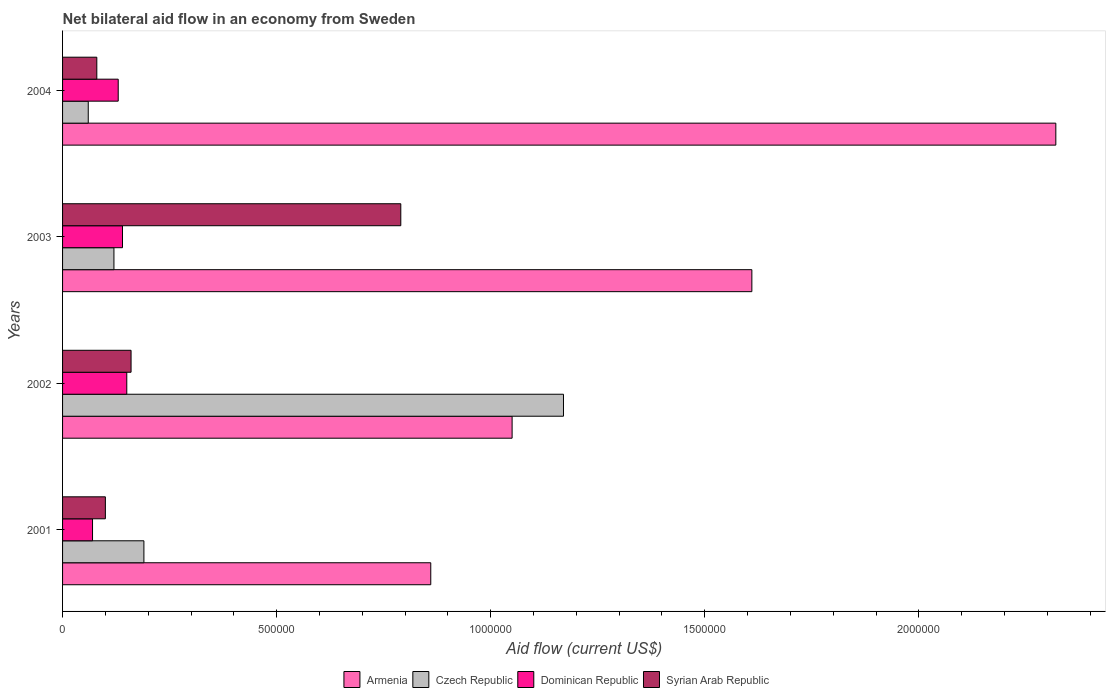How many groups of bars are there?
Make the answer very short. 4. How many bars are there on the 1st tick from the top?
Your response must be concise. 4. What is the net bilateral aid flow in Armenia in 2001?
Your answer should be very brief. 8.60e+05. Across all years, what is the maximum net bilateral aid flow in Syrian Arab Republic?
Provide a succinct answer. 7.90e+05. Across all years, what is the minimum net bilateral aid flow in Czech Republic?
Make the answer very short. 6.00e+04. In which year was the net bilateral aid flow in Armenia minimum?
Your answer should be very brief. 2001. What is the total net bilateral aid flow in Syrian Arab Republic in the graph?
Ensure brevity in your answer.  1.13e+06. What is the average net bilateral aid flow in Armenia per year?
Your response must be concise. 1.46e+06. In the year 2003, what is the difference between the net bilateral aid flow in Czech Republic and net bilateral aid flow in Armenia?
Give a very brief answer. -1.49e+06. What is the ratio of the net bilateral aid flow in Dominican Republic in 2001 to that in 2002?
Your response must be concise. 0.47. Is the net bilateral aid flow in Dominican Republic in 2001 less than that in 2003?
Give a very brief answer. Yes. Is the difference between the net bilateral aid flow in Czech Republic in 2001 and 2003 greater than the difference between the net bilateral aid flow in Armenia in 2001 and 2003?
Your answer should be very brief. Yes. What is the difference between the highest and the second highest net bilateral aid flow in Czech Republic?
Offer a terse response. 9.80e+05. In how many years, is the net bilateral aid flow in Dominican Republic greater than the average net bilateral aid flow in Dominican Republic taken over all years?
Offer a terse response. 3. Is the sum of the net bilateral aid flow in Czech Republic in 2001 and 2003 greater than the maximum net bilateral aid flow in Syrian Arab Republic across all years?
Offer a very short reply. No. What does the 1st bar from the top in 2003 represents?
Provide a short and direct response. Syrian Arab Republic. What does the 3rd bar from the bottom in 2003 represents?
Keep it short and to the point. Dominican Republic. Is it the case that in every year, the sum of the net bilateral aid flow in Dominican Republic and net bilateral aid flow in Syrian Arab Republic is greater than the net bilateral aid flow in Czech Republic?
Your answer should be very brief. No. How many bars are there?
Provide a short and direct response. 16. What is the difference between two consecutive major ticks on the X-axis?
Ensure brevity in your answer.  5.00e+05. How many legend labels are there?
Give a very brief answer. 4. What is the title of the graph?
Ensure brevity in your answer.  Net bilateral aid flow in an economy from Sweden. What is the label or title of the Y-axis?
Provide a succinct answer. Years. What is the Aid flow (current US$) in Armenia in 2001?
Give a very brief answer. 8.60e+05. What is the Aid flow (current US$) of Czech Republic in 2001?
Offer a terse response. 1.90e+05. What is the Aid flow (current US$) in Armenia in 2002?
Provide a short and direct response. 1.05e+06. What is the Aid flow (current US$) of Czech Republic in 2002?
Offer a very short reply. 1.17e+06. What is the Aid flow (current US$) of Armenia in 2003?
Your answer should be compact. 1.61e+06. What is the Aid flow (current US$) in Czech Republic in 2003?
Your answer should be compact. 1.20e+05. What is the Aid flow (current US$) of Syrian Arab Republic in 2003?
Offer a very short reply. 7.90e+05. What is the Aid flow (current US$) in Armenia in 2004?
Offer a very short reply. 2.32e+06. What is the Aid flow (current US$) of Czech Republic in 2004?
Provide a short and direct response. 6.00e+04. What is the Aid flow (current US$) in Dominican Republic in 2004?
Ensure brevity in your answer.  1.30e+05. Across all years, what is the maximum Aid flow (current US$) in Armenia?
Keep it short and to the point. 2.32e+06. Across all years, what is the maximum Aid flow (current US$) in Czech Republic?
Your response must be concise. 1.17e+06. Across all years, what is the maximum Aid flow (current US$) in Dominican Republic?
Your answer should be compact. 1.50e+05. Across all years, what is the maximum Aid flow (current US$) in Syrian Arab Republic?
Your response must be concise. 7.90e+05. Across all years, what is the minimum Aid flow (current US$) of Armenia?
Offer a very short reply. 8.60e+05. Across all years, what is the minimum Aid flow (current US$) of Syrian Arab Republic?
Your answer should be very brief. 8.00e+04. What is the total Aid flow (current US$) of Armenia in the graph?
Provide a succinct answer. 5.84e+06. What is the total Aid flow (current US$) in Czech Republic in the graph?
Your response must be concise. 1.54e+06. What is the total Aid flow (current US$) in Dominican Republic in the graph?
Keep it short and to the point. 4.90e+05. What is the total Aid flow (current US$) in Syrian Arab Republic in the graph?
Offer a terse response. 1.13e+06. What is the difference between the Aid flow (current US$) of Czech Republic in 2001 and that in 2002?
Give a very brief answer. -9.80e+05. What is the difference between the Aid flow (current US$) of Armenia in 2001 and that in 2003?
Offer a very short reply. -7.50e+05. What is the difference between the Aid flow (current US$) in Syrian Arab Republic in 2001 and that in 2003?
Provide a short and direct response. -6.90e+05. What is the difference between the Aid flow (current US$) in Armenia in 2001 and that in 2004?
Your answer should be very brief. -1.46e+06. What is the difference between the Aid flow (current US$) of Syrian Arab Republic in 2001 and that in 2004?
Offer a terse response. 2.00e+04. What is the difference between the Aid flow (current US$) of Armenia in 2002 and that in 2003?
Your response must be concise. -5.60e+05. What is the difference between the Aid flow (current US$) in Czech Republic in 2002 and that in 2003?
Ensure brevity in your answer.  1.05e+06. What is the difference between the Aid flow (current US$) in Dominican Republic in 2002 and that in 2003?
Keep it short and to the point. 10000. What is the difference between the Aid flow (current US$) in Syrian Arab Republic in 2002 and that in 2003?
Make the answer very short. -6.30e+05. What is the difference between the Aid flow (current US$) of Armenia in 2002 and that in 2004?
Keep it short and to the point. -1.27e+06. What is the difference between the Aid flow (current US$) in Czech Republic in 2002 and that in 2004?
Provide a succinct answer. 1.11e+06. What is the difference between the Aid flow (current US$) of Dominican Republic in 2002 and that in 2004?
Give a very brief answer. 2.00e+04. What is the difference between the Aid flow (current US$) of Syrian Arab Republic in 2002 and that in 2004?
Your answer should be very brief. 8.00e+04. What is the difference between the Aid flow (current US$) in Armenia in 2003 and that in 2004?
Offer a very short reply. -7.10e+05. What is the difference between the Aid flow (current US$) of Czech Republic in 2003 and that in 2004?
Your response must be concise. 6.00e+04. What is the difference between the Aid flow (current US$) in Dominican Republic in 2003 and that in 2004?
Your answer should be very brief. 10000. What is the difference between the Aid flow (current US$) in Syrian Arab Republic in 2003 and that in 2004?
Make the answer very short. 7.10e+05. What is the difference between the Aid flow (current US$) in Armenia in 2001 and the Aid flow (current US$) in Czech Republic in 2002?
Provide a succinct answer. -3.10e+05. What is the difference between the Aid flow (current US$) of Armenia in 2001 and the Aid flow (current US$) of Dominican Republic in 2002?
Give a very brief answer. 7.10e+05. What is the difference between the Aid flow (current US$) in Czech Republic in 2001 and the Aid flow (current US$) in Dominican Republic in 2002?
Give a very brief answer. 4.00e+04. What is the difference between the Aid flow (current US$) in Armenia in 2001 and the Aid flow (current US$) in Czech Republic in 2003?
Provide a succinct answer. 7.40e+05. What is the difference between the Aid flow (current US$) in Armenia in 2001 and the Aid flow (current US$) in Dominican Republic in 2003?
Ensure brevity in your answer.  7.20e+05. What is the difference between the Aid flow (current US$) in Armenia in 2001 and the Aid flow (current US$) in Syrian Arab Republic in 2003?
Your answer should be compact. 7.00e+04. What is the difference between the Aid flow (current US$) of Czech Republic in 2001 and the Aid flow (current US$) of Syrian Arab Republic in 2003?
Offer a terse response. -6.00e+05. What is the difference between the Aid flow (current US$) of Dominican Republic in 2001 and the Aid flow (current US$) of Syrian Arab Republic in 2003?
Your response must be concise. -7.20e+05. What is the difference between the Aid flow (current US$) of Armenia in 2001 and the Aid flow (current US$) of Czech Republic in 2004?
Your answer should be compact. 8.00e+05. What is the difference between the Aid flow (current US$) in Armenia in 2001 and the Aid flow (current US$) in Dominican Republic in 2004?
Keep it short and to the point. 7.30e+05. What is the difference between the Aid flow (current US$) of Armenia in 2001 and the Aid flow (current US$) of Syrian Arab Republic in 2004?
Offer a terse response. 7.80e+05. What is the difference between the Aid flow (current US$) of Czech Republic in 2001 and the Aid flow (current US$) of Dominican Republic in 2004?
Your response must be concise. 6.00e+04. What is the difference between the Aid flow (current US$) of Armenia in 2002 and the Aid flow (current US$) of Czech Republic in 2003?
Make the answer very short. 9.30e+05. What is the difference between the Aid flow (current US$) in Armenia in 2002 and the Aid flow (current US$) in Dominican Republic in 2003?
Your response must be concise. 9.10e+05. What is the difference between the Aid flow (current US$) of Armenia in 2002 and the Aid flow (current US$) of Syrian Arab Republic in 2003?
Give a very brief answer. 2.60e+05. What is the difference between the Aid flow (current US$) of Czech Republic in 2002 and the Aid flow (current US$) of Dominican Republic in 2003?
Your answer should be compact. 1.03e+06. What is the difference between the Aid flow (current US$) in Dominican Republic in 2002 and the Aid flow (current US$) in Syrian Arab Republic in 2003?
Keep it short and to the point. -6.40e+05. What is the difference between the Aid flow (current US$) of Armenia in 2002 and the Aid flow (current US$) of Czech Republic in 2004?
Give a very brief answer. 9.90e+05. What is the difference between the Aid flow (current US$) of Armenia in 2002 and the Aid flow (current US$) of Dominican Republic in 2004?
Your answer should be compact. 9.20e+05. What is the difference between the Aid flow (current US$) of Armenia in 2002 and the Aid flow (current US$) of Syrian Arab Republic in 2004?
Ensure brevity in your answer.  9.70e+05. What is the difference between the Aid flow (current US$) in Czech Republic in 2002 and the Aid flow (current US$) in Dominican Republic in 2004?
Offer a very short reply. 1.04e+06. What is the difference between the Aid flow (current US$) in Czech Republic in 2002 and the Aid flow (current US$) in Syrian Arab Republic in 2004?
Provide a succinct answer. 1.09e+06. What is the difference between the Aid flow (current US$) in Dominican Republic in 2002 and the Aid flow (current US$) in Syrian Arab Republic in 2004?
Make the answer very short. 7.00e+04. What is the difference between the Aid flow (current US$) of Armenia in 2003 and the Aid flow (current US$) of Czech Republic in 2004?
Offer a terse response. 1.55e+06. What is the difference between the Aid flow (current US$) in Armenia in 2003 and the Aid flow (current US$) in Dominican Republic in 2004?
Your answer should be very brief. 1.48e+06. What is the difference between the Aid flow (current US$) in Armenia in 2003 and the Aid flow (current US$) in Syrian Arab Republic in 2004?
Provide a succinct answer. 1.53e+06. What is the difference between the Aid flow (current US$) in Dominican Republic in 2003 and the Aid flow (current US$) in Syrian Arab Republic in 2004?
Offer a very short reply. 6.00e+04. What is the average Aid flow (current US$) of Armenia per year?
Provide a short and direct response. 1.46e+06. What is the average Aid flow (current US$) of Czech Republic per year?
Provide a succinct answer. 3.85e+05. What is the average Aid flow (current US$) of Dominican Republic per year?
Your answer should be compact. 1.22e+05. What is the average Aid flow (current US$) in Syrian Arab Republic per year?
Keep it short and to the point. 2.82e+05. In the year 2001, what is the difference between the Aid flow (current US$) in Armenia and Aid flow (current US$) in Czech Republic?
Keep it short and to the point. 6.70e+05. In the year 2001, what is the difference between the Aid flow (current US$) in Armenia and Aid flow (current US$) in Dominican Republic?
Offer a terse response. 7.90e+05. In the year 2001, what is the difference between the Aid flow (current US$) in Armenia and Aid flow (current US$) in Syrian Arab Republic?
Your answer should be very brief. 7.60e+05. In the year 2001, what is the difference between the Aid flow (current US$) in Czech Republic and Aid flow (current US$) in Syrian Arab Republic?
Your response must be concise. 9.00e+04. In the year 2001, what is the difference between the Aid flow (current US$) of Dominican Republic and Aid flow (current US$) of Syrian Arab Republic?
Make the answer very short. -3.00e+04. In the year 2002, what is the difference between the Aid flow (current US$) in Armenia and Aid flow (current US$) in Czech Republic?
Keep it short and to the point. -1.20e+05. In the year 2002, what is the difference between the Aid flow (current US$) in Armenia and Aid flow (current US$) in Syrian Arab Republic?
Your answer should be very brief. 8.90e+05. In the year 2002, what is the difference between the Aid flow (current US$) of Czech Republic and Aid flow (current US$) of Dominican Republic?
Offer a terse response. 1.02e+06. In the year 2002, what is the difference between the Aid flow (current US$) of Czech Republic and Aid flow (current US$) of Syrian Arab Republic?
Give a very brief answer. 1.01e+06. In the year 2003, what is the difference between the Aid flow (current US$) in Armenia and Aid flow (current US$) in Czech Republic?
Your answer should be compact. 1.49e+06. In the year 2003, what is the difference between the Aid flow (current US$) of Armenia and Aid flow (current US$) of Dominican Republic?
Offer a very short reply. 1.47e+06. In the year 2003, what is the difference between the Aid flow (current US$) of Armenia and Aid flow (current US$) of Syrian Arab Republic?
Offer a terse response. 8.20e+05. In the year 2003, what is the difference between the Aid flow (current US$) in Czech Republic and Aid flow (current US$) in Syrian Arab Republic?
Your answer should be very brief. -6.70e+05. In the year 2003, what is the difference between the Aid flow (current US$) of Dominican Republic and Aid flow (current US$) of Syrian Arab Republic?
Offer a terse response. -6.50e+05. In the year 2004, what is the difference between the Aid flow (current US$) in Armenia and Aid flow (current US$) in Czech Republic?
Make the answer very short. 2.26e+06. In the year 2004, what is the difference between the Aid flow (current US$) of Armenia and Aid flow (current US$) of Dominican Republic?
Your answer should be compact. 2.19e+06. In the year 2004, what is the difference between the Aid flow (current US$) of Armenia and Aid flow (current US$) of Syrian Arab Republic?
Give a very brief answer. 2.24e+06. In the year 2004, what is the difference between the Aid flow (current US$) in Czech Republic and Aid flow (current US$) in Dominican Republic?
Your answer should be compact. -7.00e+04. In the year 2004, what is the difference between the Aid flow (current US$) of Dominican Republic and Aid flow (current US$) of Syrian Arab Republic?
Ensure brevity in your answer.  5.00e+04. What is the ratio of the Aid flow (current US$) in Armenia in 2001 to that in 2002?
Your answer should be very brief. 0.82. What is the ratio of the Aid flow (current US$) in Czech Republic in 2001 to that in 2002?
Give a very brief answer. 0.16. What is the ratio of the Aid flow (current US$) in Dominican Republic in 2001 to that in 2002?
Your answer should be compact. 0.47. What is the ratio of the Aid flow (current US$) of Syrian Arab Republic in 2001 to that in 2002?
Your answer should be very brief. 0.62. What is the ratio of the Aid flow (current US$) in Armenia in 2001 to that in 2003?
Provide a short and direct response. 0.53. What is the ratio of the Aid flow (current US$) of Czech Republic in 2001 to that in 2003?
Your answer should be very brief. 1.58. What is the ratio of the Aid flow (current US$) of Syrian Arab Republic in 2001 to that in 2003?
Offer a very short reply. 0.13. What is the ratio of the Aid flow (current US$) of Armenia in 2001 to that in 2004?
Provide a short and direct response. 0.37. What is the ratio of the Aid flow (current US$) in Czech Republic in 2001 to that in 2004?
Ensure brevity in your answer.  3.17. What is the ratio of the Aid flow (current US$) in Dominican Republic in 2001 to that in 2004?
Offer a terse response. 0.54. What is the ratio of the Aid flow (current US$) of Armenia in 2002 to that in 2003?
Your response must be concise. 0.65. What is the ratio of the Aid flow (current US$) of Czech Republic in 2002 to that in 2003?
Make the answer very short. 9.75. What is the ratio of the Aid flow (current US$) of Dominican Republic in 2002 to that in 2003?
Your answer should be compact. 1.07. What is the ratio of the Aid flow (current US$) in Syrian Arab Republic in 2002 to that in 2003?
Your response must be concise. 0.2. What is the ratio of the Aid flow (current US$) of Armenia in 2002 to that in 2004?
Your response must be concise. 0.45. What is the ratio of the Aid flow (current US$) in Dominican Republic in 2002 to that in 2004?
Your answer should be very brief. 1.15. What is the ratio of the Aid flow (current US$) of Syrian Arab Republic in 2002 to that in 2004?
Your response must be concise. 2. What is the ratio of the Aid flow (current US$) of Armenia in 2003 to that in 2004?
Provide a short and direct response. 0.69. What is the ratio of the Aid flow (current US$) in Syrian Arab Republic in 2003 to that in 2004?
Give a very brief answer. 9.88. What is the difference between the highest and the second highest Aid flow (current US$) in Armenia?
Keep it short and to the point. 7.10e+05. What is the difference between the highest and the second highest Aid flow (current US$) of Czech Republic?
Your answer should be very brief. 9.80e+05. What is the difference between the highest and the second highest Aid flow (current US$) in Dominican Republic?
Give a very brief answer. 10000. What is the difference between the highest and the second highest Aid flow (current US$) in Syrian Arab Republic?
Offer a very short reply. 6.30e+05. What is the difference between the highest and the lowest Aid flow (current US$) in Armenia?
Provide a short and direct response. 1.46e+06. What is the difference between the highest and the lowest Aid flow (current US$) of Czech Republic?
Your response must be concise. 1.11e+06. What is the difference between the highest and the lowest Aid flow (current US$) of Dominican Republic?
Your answer should be very brief. 8.00e+04. What is the difference between the highest and the lowest Aid flow (current US$) in Syrian Arab Republic?
Provide a short and direct response. 7.10e+05. 